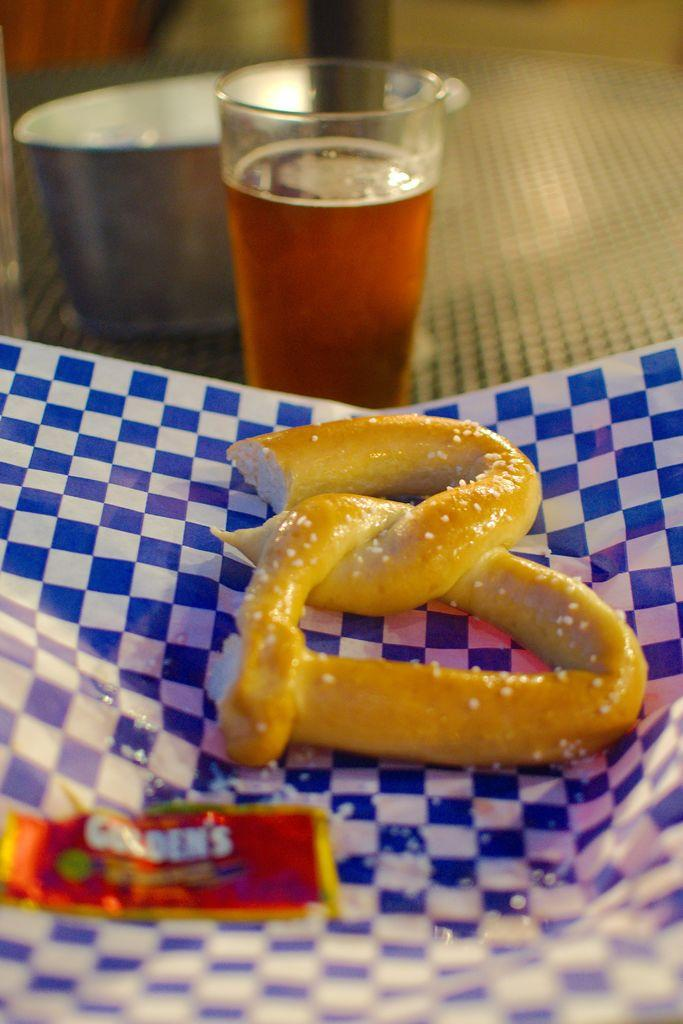What is the main subject in the foreground of the image? There is a pretzel on a cover in the foreground of the image. What other objects can be seen in the image? There is a glass and a bowl in the image. How would you describe the background of the image? The background of the image is blurred. What type of hammer is being used to transport the banana in the image? There is no hammer or banana present in the image. 